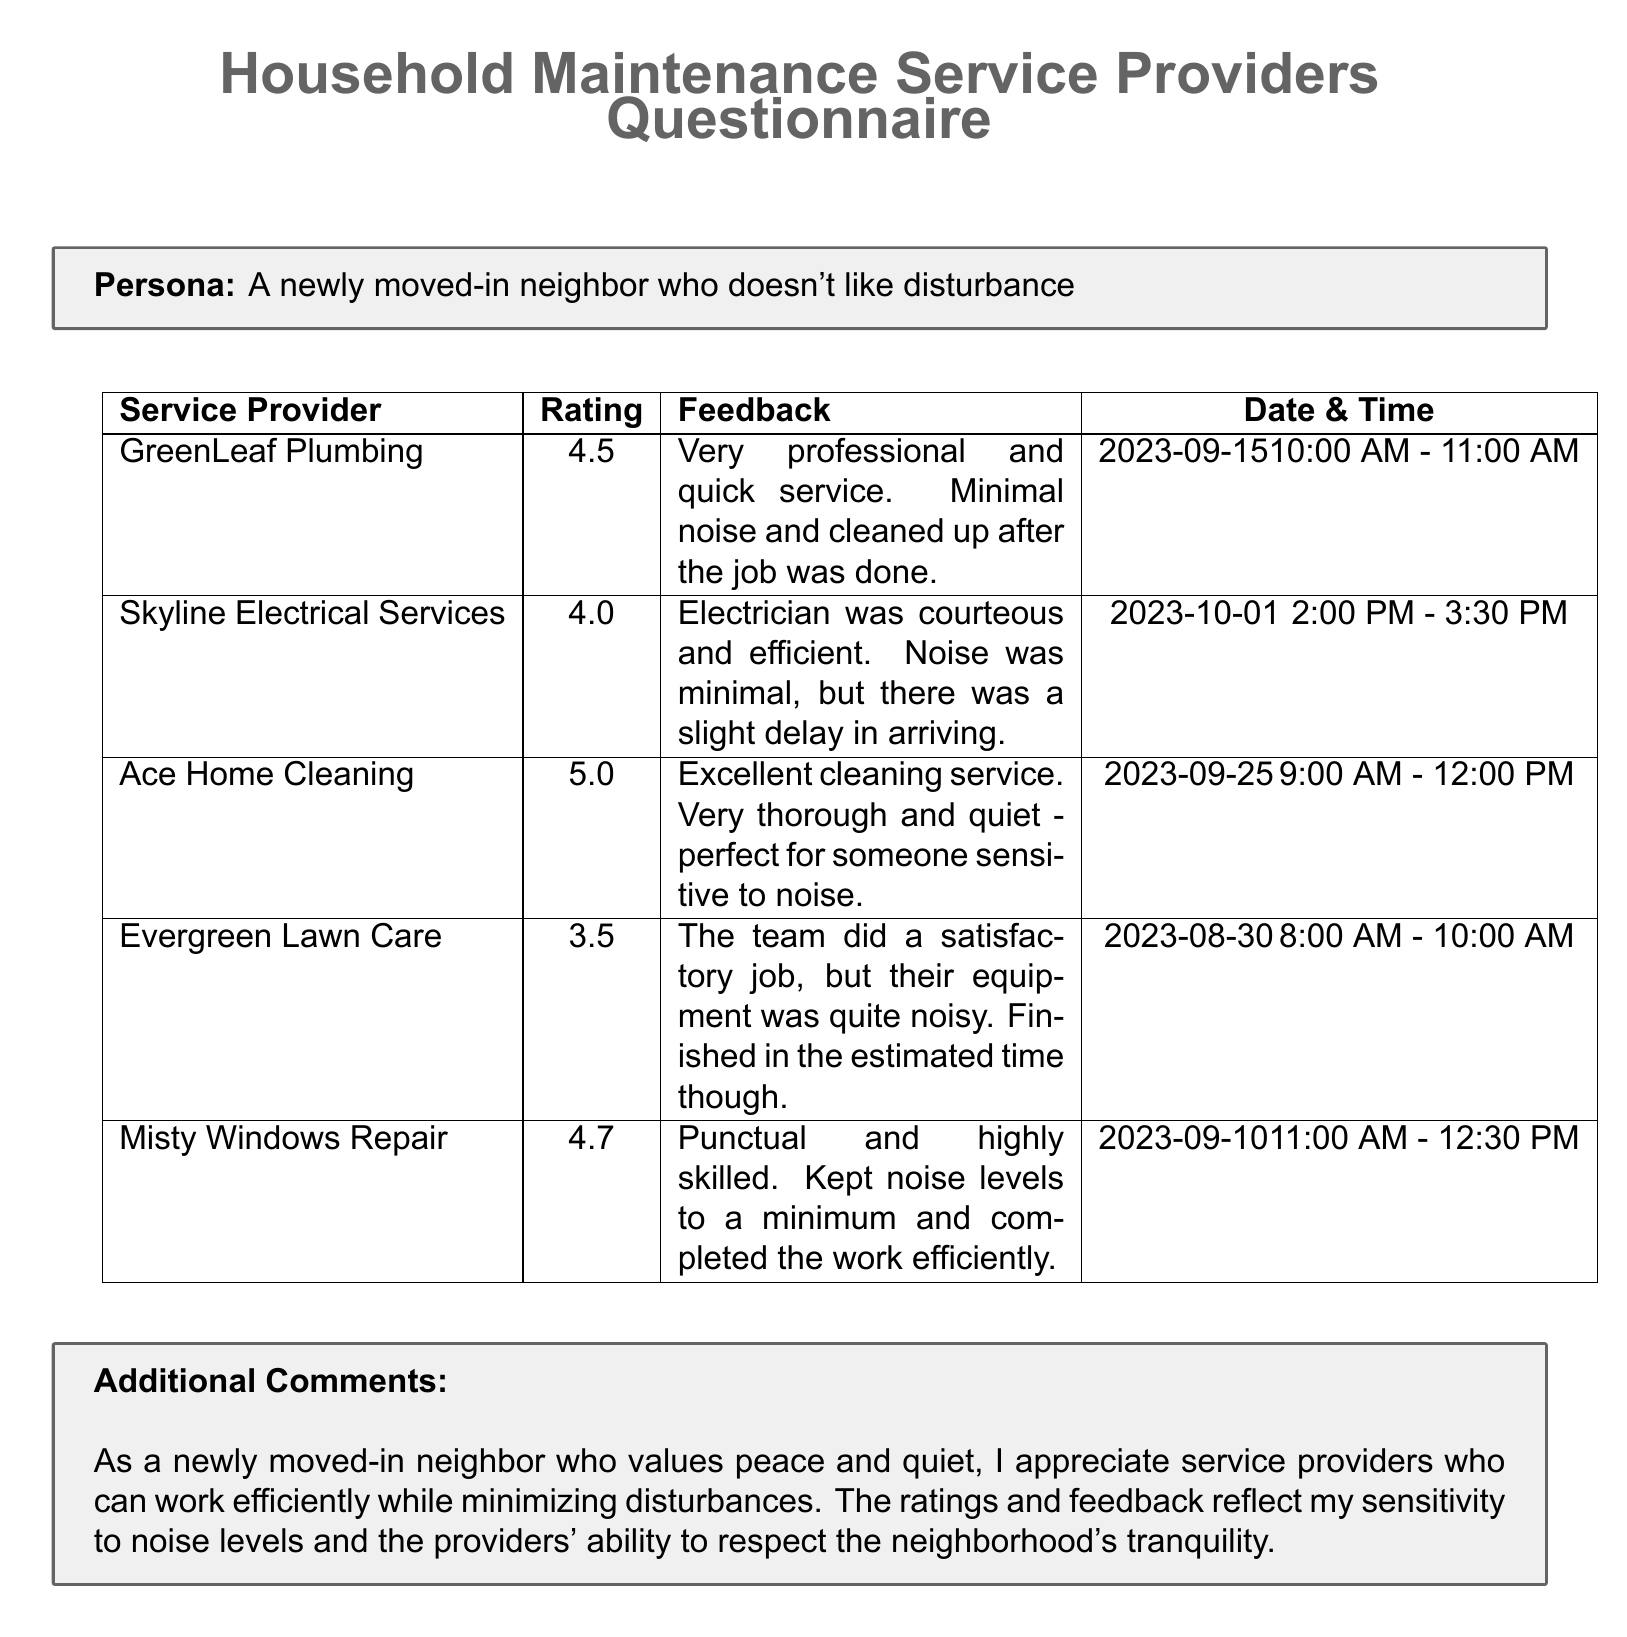what is the rating for GreenLeaf Plumbing? The rating for GreenLeaf Plumbing is listed in the document under the Ratings column.
Answer: 4.5 what was the date and time of the service provided by Skyline Electrical Services? The date and time for Skyline Electrical Services can be found in the Date & Time column of the document.
Answer: 2023-10-01 2:00 PM - 3:30 PM which service provider received the highest rating? The highest rating in the Ratings column indicates which provider performed best.
Answer: Ace Home Cleaning how much noise did Evergreen Lawn Care generate? The feedback for Evergreen Lawn Care mentions the noise levels made by the team's equipment.
Answer: Quite noisy which service provider completed their work efficiently and kept noise levels to a minimum? The document specifies which provider managed their noise level while working efficiently.
Answer: Misty Windows Repair 